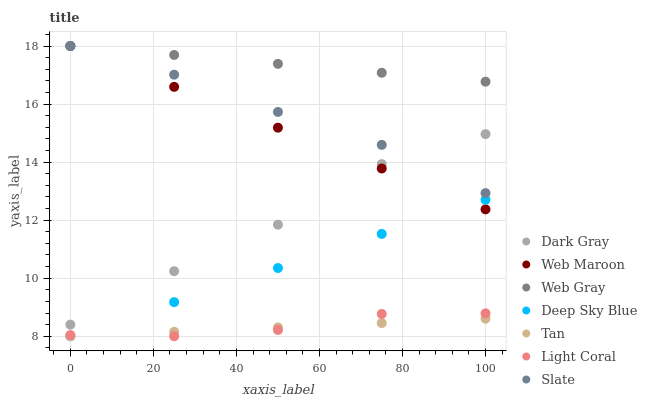Does Tan have the minimum area under the curve?
Answer yes or no. Yes. Does Web Gray have the maximum area under the curve?
Answer yes or no. Yes. Does Slate have the minimum area under the curve?
Answer yes or no. No. Does Slate have the maximum area under the curve?
Answer yes or no. No. Is Web Gray the smoothest?
Answer yes or no. Yes. Is Dark Gray the roughest?
Answer yes or no. Yes. Is Slate the smoothest?
Answer yes or no. No. Is Slate the roughest?
Answer yes or no. No. Does Light Coral have the lowest value?
Answer yes or no. Yes. Does Slate have the lowest value?
Answer yes or no. No. Does Web Maroon have the highest value?
Answer yes or no. Yes. Does Dark Gray have the highest value?
Answer yes or no. No. Is Deep Sky Blue less than Dark Gray?
Answer yes or no. Yes. Is Web Gray greater than Dark Gray?
Answer yes or no. Yes. Does Light Coral intersect Tan?
Answer yes or no. Yes. Is Light Coral less than Tan?
Answer yes or no. No. Is Light Coral greater than Tan?
Answer yes or no. No. Does Deep Sky Blue intersect Dark Gray?
Answer yes or no. No. 